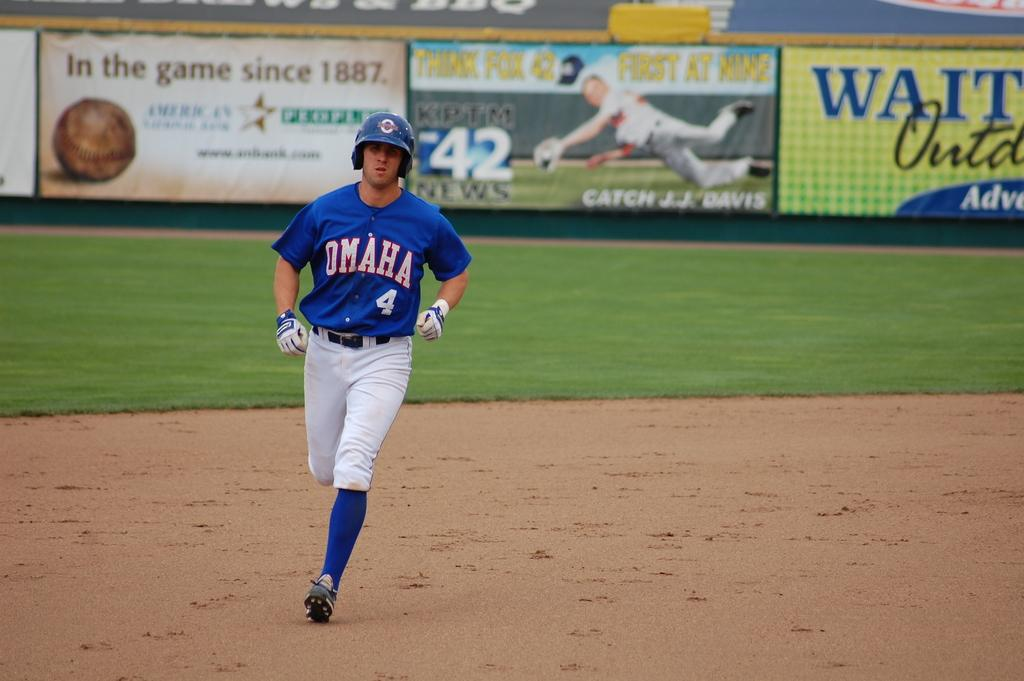<image>
Write a terse but informative summary of the picture. A baseball player is running for the next baseball and his uniform says Omaha. 